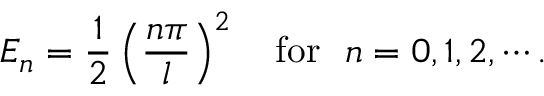Convert formula to latex. <formula><loc_0><loc_0><loc_500><loc_500>E _ { n } = \frac { 1 } { 2 } \left ( \frac { n \pi } { l } \right ) ^ { 2 } \quad f o r n = 0 , 1 , 2 , \cdots .</formula> 